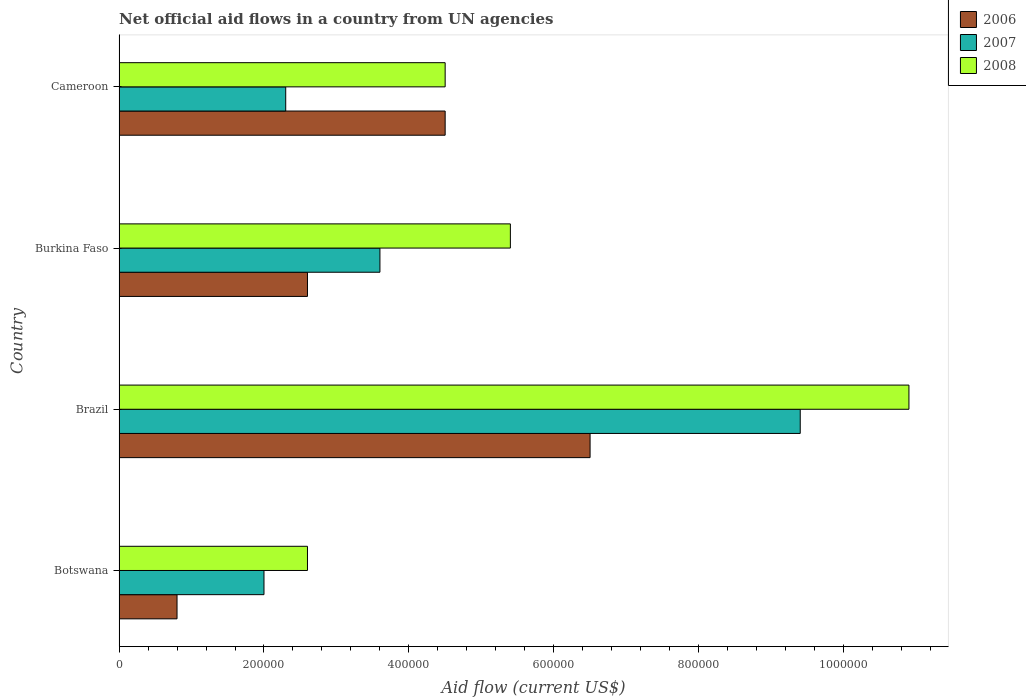How many groups of bars are there?
Provide a succinct answer. 4. Are the number of bars per tick equal to the number of legend labels?
Offer a terse response. Yes. How many bars are there on the 4th tick from the top?
Your response must be concise. 3. How many bars are there on the 1st tick from the bottom?
Your answer should be very brief. 3. What is the label of the 1st group of bars from the top?
Keep it short and to the point. Cameroon. What is the net official aid flow in 2008 in Burkina Faso?
Ensure brevity in your answer.  5.40e+05. Across all countries, what is the maximum net official aid flow in 2007?
Your answer should be very brief. 9.40e+05. Across all countries, what is the minimum net official aid flow in 2008?
Your answer should be compact. 2.60e+05. In which country was the net official aid flow in 2006 minimum?
Give a very brief answer. Botswana. What is the total net official aid flow in 2006 in the graph?
Your answer should be compact. 1.44e+06. What is the difference between the net official aid flow in 2008 in Burkina Faso and that in Cameroon?
Offer a terse response. 9.00e+04. What is the average net official aid flow in 2007 per country?
Make the answer very short. 4.32e+05. In how many countries, is the net official aid flow in 2007 greater than 320000 US$?
Give a very brief answer. 2. What is the difference between the highest and the lowest net official aid flow in 2006?
Give a very brief answer. 5.70e+05. In how many countries, is the net official aid flow in 2008 greater than the average net official aid flow in 2008 taken over all countries?
Your answer should be compact. 1. Is the sum of the net official aid flow in 2007 in Botswana and Burkina Faso greater than the maximum net official aid flow in 2008 across all countries?
Offer a very short reply. No. What does the 3rd bar from the top in Brazil represents?
Ensure brevity in your answer.  2006. What does the 3rd bar from the bottom in Cameroon represents?
Give a very brief answer. 2008. Is it the case that in every country, the sum of the net official aid flow in 2006 and net official aid flow in 2007 is greater than the net official aid flow in 2008?
Offer a very short reply. Yes. How many bars are there?
Your answer should be very brief. 12. What is the difference between two consecutive major ticks on the X-axis?
Provide a succinct answer. 2.00e+05. Are the values on the major ticks of X-axis written in scientific E-notation?
Your answer should be compact. No. Does the graph contain any zero values?
Make the answer very short. No. Where does the legend appear in the graph?
Your response must be concise. Top right. What is the title of the graph?
Your answer should be compact. Net official aid flows in a country from UN agencies. Does "1976" appear as one of the legend labels in the graph?
Your answer should be very brief. No. What is the Aid flow (current US$) of 2007 in Botswana?
Provide a short and direct response. 2.00e+05. What is the Aid flow (current US$) of 2008 in Botswana?
Provide a short and direct response. 2.60e+05. What is the Aid flow (current US$) of 2006 in Brazil?
Offer a very short reply. 6.50e+05. What is the Aid flow (current US$) of 2007 in Brazil?
Provide a short and direct response. 9.40e+05. What is the Aid flow (current US$) of 2008 in Brazil?
Your response must be concise. 1.09e+06. What is the Aid flow (current US$) in 2008 in Burkina Faso?
Provide a succinct answer. 5.40e+05. What is the Aid flow (current US$) of 2006 in Cameroon?
Keep it short and to the point. 4.50e+05. What is the Aid flow (current US$) of 2007 in Cameroon?
Ensure brevity in your answer.  2.30e+05. What is the Aid flow (current US$) of 2008 in Cameroon?
Provide a short and direct response. 4.50e+05. Across all countries, what is the maximum Aid flow (current US$) of 2006?
Ensure brevity in your answer.  6.50e+05. Across all countries, what is the maximum Aid flow (current US$) of 2007?
Your response must be concise. 9.40e+05. Across all countries, what is the maximum Aid flow (current US$) in 2008?
Your response must be concise. 1.09e+06. Across all countries, what is the minimum Aid flow (current US$) in 2007?
Give a very brief answer. 2.00e+05. What is the total Aid flow (current US$) in 2006 in the graph?
Your answer should be compact. 1.44e+06. What is the total Aid flow (current US$) of 2007 in the graph?
Give a very brief answer. 1.73e+06. What is the total Aid flow (current US$) of 2008 in the graph?
Your answer should be very brief. 2.34e+06. What is the difference between the Aid flow (current US$) in 2006 in Botswana and that in Brazil?
Provide a succinct answer. -5.70e+05. What is the difference between the Aid flow (current US$) of 2007 in Botswana and that in Brazil?
Provide a succinct answer. -7.40e+05. What is the difference between the Aid flow (current US$) in 2008 in Botswana and that in Brazil?
Ensure brevity in your answer.  -8.30e+05. What is the difference between the Aid flow (current US$) of 2006 in Botswana and that in Burkina Faso?
Offer a very short reply. -1.80e+05. What is the difference between the Aid flow (current US$) of 2007 in Botswana and that in Burkina Faso?
Offer a terse response. -1.60e+05. What is the difference between the Aid flow (current US$) of 2008 in Botswana and that in Burkina Faso?
Give a very brief answer. -2.80e+05. What is the difference between the Aid flow (current US$) in 2006 in Botswana and that in Cameroon?
Provide a succinct answer. -3.70e+05. What is the difference between the Aid flow (current US$) of 2008 in Botswana and that in Cameroon?
Give a very brief answer. -1.90e+05. What is the difference between the Aid flow (current US$) in 2006 in Brazil and that in Burkina Faso?
Offer a terse response. 3.90e+05. What is the difference between the Aid flow (current US$) in 2007 in Brazil and that in Burkina Faso?
Your response must be concise. 5.80e+05. What is the difference between the Aid flow (current US$) of 2008 in Brazil and that in Burkina Faso?
Provide a short and direct response. 5.50e+05. What is the difference between the Aid flow (current US$) of 2006 in Brazil and that in Cameroon?
Your answer should be very brief. 2.00e+05. What is the difference between the Aid flow (current US$) in 2007 in Brazil and that in Cameroon?
Make the answer very short. 7.10e+05. What is the difference between the Aid flow (current US$) of 2008 in Brazil and that in Cameroon?
Offer a very short reply. 6.40e+05. What is the difference between the Aid flow (current US$) in 2006 in Botswana and the Aid flow (current US$) in 2007 in Brazil?
Offer a terse response. -8.60e+05. What is the difference between the Aid flow (current US$) of 2006 in Botswana and the Aid flow (current US$) of 2008 in Brazil?
Your answer should be very brief. -1.01e+06. What is the difference between the Aid flow (current US$) of 2007 in Botswana and the Aid flow (current US$) of 2008 in Brazil?
Ensure brevity in your answer.  -8.90e+05. What is the difference between the Aid flow (current US$) of 2006 in Botswana and the Aid flow (current US$) of 2007 in Burkina Faso?
Offer a terse response. -2.80e+05. What is the difference between the Aid flow (current US$) of 2006 in Botswana and the Aid flow (current US$) of 2008 in Burkina Faso?
Provide a short and direct response. -4.60e+05. What is the difference between the Aid flow (current US$) in 2007 in Botswana and the Aid flow (current US$) in 2008 in Burkina Faso?
Make the answer very short. -3.40e+05. What is the difference between the Aid flow (current US$) in 2006 in Botswana and the Aid flow (current US$) in 2008 in Cameroon?
Your response must be concise. -3.70e+05. What is the difference between the Aid flow (current US$) of 2007 in Botswana and the Aid flow (current US$) of 2008 in Cameroon?
Give a very brief answer. -2.50e+05. What is the difference between the Aid flow (current US$) in 2006 in Brazil and the Aid flow (current US$) in 2007 in Burkina Faso?
Offer a very short reply. 2.90e+05. What is the difference between the Aid flow (current US$) in 2006 in Brazil and the Aid flow (current US$) in 2008 in Cameroon?
Give a very brief answer. 2.00e+05. What is the difference between the Aid flow (current US$) in 2006 in Burkina Faso and the Aid flow (current US$) in 2007 in Cameroon?
Provide a short and direct response. 3.00e+04. What is the difference between the Aid flow (current US$) of 2006 in Burkina Faso and the Aid flow (current US$) of 2008 in Cameroon?
Offer a very short reply. -1.90e+05. What is the difference between the Aid flow (current US$) of 2007 in Burkina Faso and the Aid flow (current US$) of 2008 in Cameroon?
Provide a succinct answer. -9.00e+04. What is the average Aid flow (current US$) of 2007 per country?
Make the answer very short. 4.32e+05. What is the average Aid flow (current US$) of 2008 per country?
Your response must be concise. 5.85e+05. What is the difference between the Aid flow (current US$) of 2006 and Aid flow (current US$) of 2007 in Botswana?
Give a very brief answer. -1.20e+05. What is the difference between the Aid flow (current US$) in 2006 and Aid flow (current US$) in 2008 in Botswana?
Give a very brief answer. -1.80e+05. What is the difference between the Aid flow (current US$) of 2007 and Aid flow (current US$) of 2008 in Botswana?
Your response must be concise. -6.00e+04. What is the difference between the Aid flow (current US$) in 2006 and Aid flow (current US$) in 2008 in Brazil?
Offer a terse response. -4.40e+05. What is the difference between the Aid flow (current US$) in 2006 and Aid flow (current US$) in 2007 in Burkina Faso?
Give a very brief answer. -1.00e+05. What is the difference between the Aid flow (current US$) in 2006 and Aid flow (current US$) in 2008 in Burkina Faso?
Provide a short and direct response. -2.80e+05. What is the difference between the Aid flow (current US$) in 2007 and Aid flow (current US$) in 2008 in Burkina Faso?
Your answer should be compact. -1.80e+05. What is the difference between the Aid flow (current US$) in 2006 and Aid flow (current US$) in 2007 in Cameroon?
Ensure brevity in your answer.  2.20e+05. What is the difference between the Aid flow (current US$) in 2006 and Aid flow (current US$) in 2008 in Cameroon?
Offer a terse response. 0. What is the difference between the Aid flow (current US$) of 2007 and Aid flow (current US$) of 2008 in Cameroon?
Offer a very short reply. -2.20e+05. What is the ratio of the Aid flow (current US$) in 2006 in Botswana to that in Brazil?
Provide a short and direct response. 0.12. What is the ratio of the Aid flow (current US$) of 2007 in Botswana to that in Brazil?
Your answer should be very brief. 0.21. What is the ratio of the Aid flow (current US$) in 2008 in Botswana to that in Brazil?
Keep it short and to the point. 0.24. What is the ratio of the Aid flow (current US$) in 2006 in Botswana to that in Burkina Faso?
Make the answer very short. 0.31. What is the ratio of the Aid flow (current US$) in 2007 in Botswana to that in Burkina Faso?
Your answer should be very brief. 0.56. What is the ratio of the Aid flow (current US$) of 2008 in Botswana to that in Burkina Faso?
Your response must be concise. 0.48. What is the ratio of the Aid flow (current US$) of 2006 in Botswana to that in Cameroon?
Ensure brevity in your answer.  0.18. What is the ratio of the Aid flow (current US$) in 2007 in Botswana to that in Cameroon?
Offer a terse response. 0.87. What is the ratio of the Aid flow (current US$) in 2008 in Botswana to that in Cameroon?
Provide a succinct answer. 0.58. What is the ratio of the Aid flow (current US$) in 2006 in Brazil to that in Burkina Faso?
Provide a short and direct response. 2.5. What is the ratio of the Aid flow (current US$) of 2007 in Brazil to that in Burkina Faso?
Make the answer very short. 2.61. What is the ratio of the Aid flow (current US$) in 2008 in Brazil to that in Burkina Faso?
Give a very brief answer. 2.02. What is the ratio of the Aid flow (current US$) in 2006 in Brazil to that in Cameroon?
Provide a short and direct response. 1.44. What is the ratio of the Aid flow (current US$) in 2007 in Brazil to that in Cameroon?
Ensure brevity in your answer.  4.09. What is the ratio of the Aid flow (current US$) in 2008 in Brazil to that in Cameroon?
Offer a terse response. 2.42. What is the ratio of the Aid flow (current US$) in 2006 in Burkina Faso to that in Cameroon?
Your response must be concise. 0.58. What is the ratio of the Aid flow (current US$) of 2007 in Burkina Faso to that in Cameroon?
Provide a succinct answer. 1.57. What is the ratio of the Aid flow (current US$) in 2008 in Burkina Faso to that in Cameroon?
Keep it short and to the point. 1.2. What is the difference between the highest and the second highest Aid flow (current US$) in 2007?
Ensure brevity in your answer.  5.80e+05. What is the difference between the highest and the lowest Aid flow (current US$) of 2006?
Your answer should be very brief. 5.70e+05. What is the difference between the highest and the lowest Aid flow (current US$) in 2007?
Keep it short and to the point. 7.40e+05. What is the difference between the highest and the lowest Aid flow (current US$) in 2008?
Give a very brief answer. 8.30e+05. 